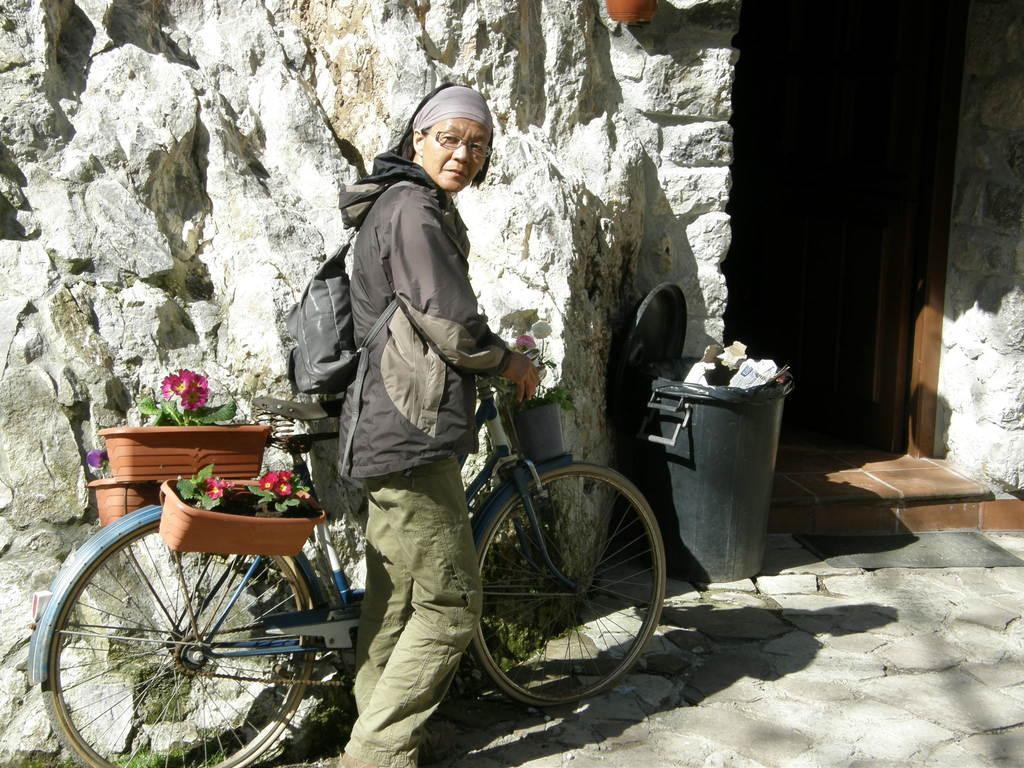Please provide a concise description of this image. This picture shows a woman holding a bicycle in her hand and we see few flower plants on the back and front of the bicycle and she wore a backpack and we see a dustbin 